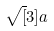Convert formula to latex. <formula><loc_0><loc_0><loc_500><loc_500>\sqrt { [ } 3 ] a</formula> 